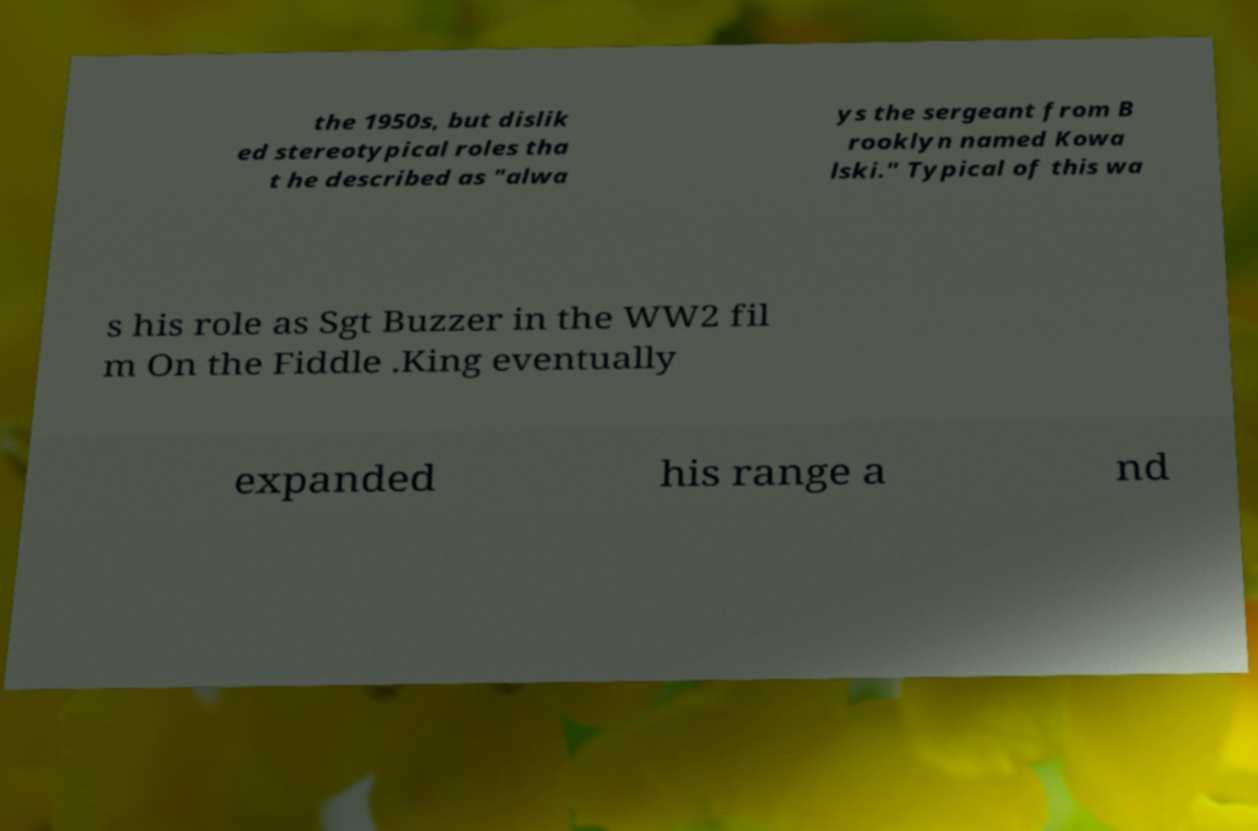I need the written content from this picture converted into text. Can you do that? the 1950s, but dislik ed stereotypical roles tha t he described as "alwa ys the sergeant from B rooklyn named Kowa lski." Typical of this wa s his role as Sgt Buzzer in the WW2 fil m On the Fiddle .King eventually expanded his range a nd 